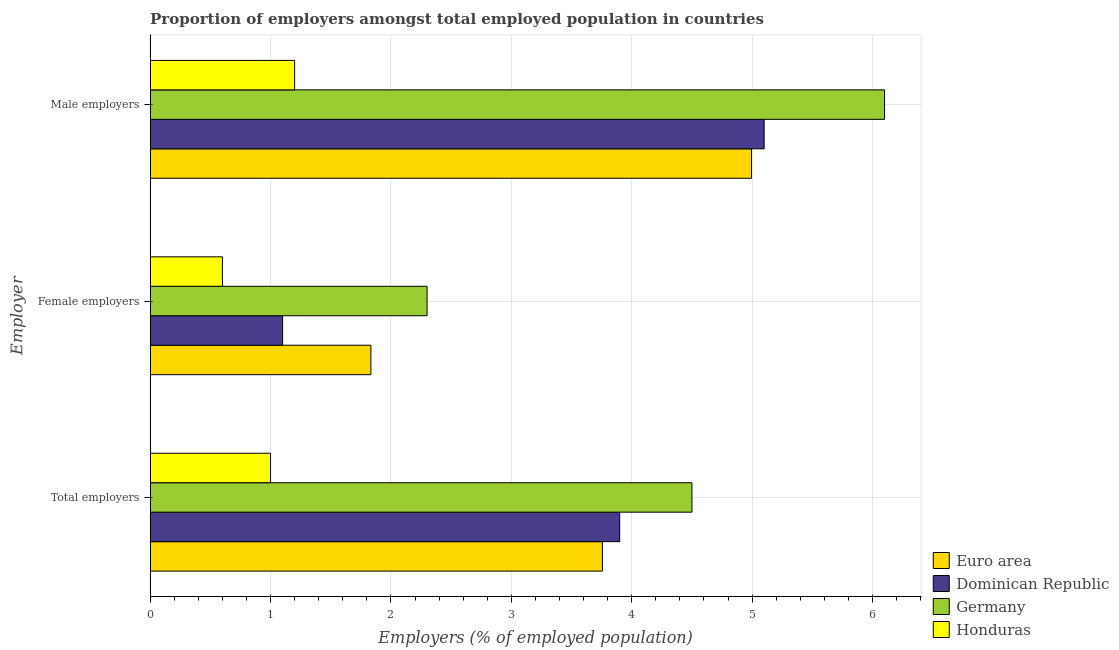How many different coloured bars are there?
Keep it short and to the point. 4. How many groups of bars are there?
Provide a short and direct response. 3. Are the number of bars on each tick of the Y-axis equal?
Your answer should be very brief. Yes. What is the label of the 2nd group of bars from the top?
Give a very brief answer. Female employers. What is the percentage of female employers in Honduras?
Your response must be concise. 0.6. Across all countries, what is the maximum percentage of female employers?
Offer a terse response. 2.3. In which country was the percentage of total employers minimum?
Your answer should be compact. Honduras. What is the total percentage of total employers in the graph?
Provide a succinct answer. 13.16. What is the difference between the percentage of total employers in Germany and that in Euro area?
Your answer should be compact. 0.74. What is the difference between the percentage of male employers in Honduras and the percentage of female employers in Germany?
Your response must be concise. -1.1. What is the average percentage of female employers per country?
Provide a succinct answer. 1.46. What is the difference between the percentage of female employers and percentage of total employers in Euro area?
Ensure brevity in your answer.  -1.92. What is the ratio of the percentage of total employers in Euro area to that in Germany?
Keep it short and to the point. 0.83. Is the difference between the percentage of total employers in Honduras and Germany greater than the difference between the percentage of female employers in Honduras and Germany?
Give a very brief answer. No. What is the difference between the highest and the second highest percentage of male employers?
Your answer should be compact. 1. What is the difference between the highest and the lowest percentage of female employers?
Give a very brief answer. 1.7. What does the 4th bar from the top in Female employers represents?
Your answer should be compact. Euro area. Is it the case that in every country, the sum of the percentage of total employers and percentage of female employers is greater than the percentage of male employers?
Your answer should be very brief. No. How many bars are there?
Make the answer very short. 12. Are all the bars in the graph horizontal?
Give a very brief answer. Yes. How many countries are there in the graph?
Keep it short and to the point. 4. What is the difference between two consecutive major ticks on the X-axis?
Your answer should be compact. 1. How many legend labels are there?
Give a very brief answer. 4. How are the legend labels stacked?
Your answer should be very brief. Vertical. What is the title of the graph?
Give a very brief answer. Proportion of employers amongst total employed population in countries. What is the label or title of the X-axis?
Your response must be concise. Employers (% of employed population). What is the label or title of the Y-axis?
Provide a short and direct response. Employer. What is the Employers (% of employed population) in Euro area in Total employers?
Offer a very short reply. 3.76. What is the Employers (% of employed population) in Dominican Republic in Total employers?
Provide a succinct answer. 3.9. What is the Employers (% of employed population) in Germany in Total employers?
Make the answer very short. 4.5. What is the Employers (% of employed population) in Euro area in Female employers?
Keep it short and to the point. 1.83. What is the Employers (% of employed population) of Dominican Republic in Female employers?
Keep it short and to the point. 1.1. What is the Employers (% of employed population) of Germany in Female employers?
Ensure brevity in your answer.  2.3. What is the Employers (% of employed population) of Honduras in Female employers?
Your response must be concise. 0.6. What is the Employers (% of employed population) in Euro area in Male employers?
Your response must be concise. 4.99. What is the Employers (% of employed population) of Dominican Republic in Male employers?
Provide a short and direct response. 5.1. What is the Employers (% of employed population) of Germany in Male employers?
Give a very brief answer. 6.1. What is the Employers (% of employed population) of Honduras in Male employers?
Provide a succinct answer. 1.2. Across all Employer, what is the maximum Employers (% of employed population) of Euro area?
Give a very brief answer. 4.99. Across all Employer, what is the maximum Employers (% of employed population) in Dominican Republic?
Your answer should be compact. 5.1. Across all Employer, what is the maximum Employers (% of employed population) of Germany?
Ensure brevity in your answer.  6.1. Across all Employer, what is the maximum Employers (% of employed population) in Honduras?
Offer a terse response. 1.2. Across all Employer, what is the minimum Employers (% of employed population) in Euro area?
Your answer should be compact. 1.83. Across all Employer, what is the minimum Employers (% of employed population) of Dominican Republic?
Ensure brevity in your answer.  1.1. Across all Employer, what is the minimum Employers (% of employed population) of Germany?
Make the answer very short. 2.3. Across all Employer, what is the minimum Employers (% of employed population) of Honduras?
Ensure brevity in your answer.  0.6. What is the total Employers (% of employed population) of Euro area in the graph?
Provide a succinct answer. 10.58. What is the total Employers (% of employed population) in Dominican Republic in the graph?
Your answer should be very brief. 10.1. What is the difference between the Employers (% of employed population) of Euro area in Total employers and that in Female employers?
Provide a succinct answer. 1.92. What is the difference between the Employers (% of employed population) in Dominican Republic in Total employers and that in Female employers?
Provide a short and direct response. 2.8. What is the difference between the Employers (% of employed population) of Euro area in Total employers and that in Male employers?
Make the answer very short. -1.24. What is the difference between the Employers (% of employed population) of Honduras in Total employers and that in Male employers?
Keep it short and to the point. -0.2. What is the difference between the Employers (% of employed population) of Euro area in Female employers and that in Male employers?
Offer a very short reply. -3.16. What is the difference between the Employers (% of employed population) in Dominican Republic in Female employers and that in Male employers?
Your response must be concise. -4. What is the difference between the Employers (% of employed population) in Euro area in Total employers and the Employers (% of employed population) in Dominican Republic in Female employers?
Your response must be concise. 2.66. What is the difference between the Employers (% of employed population) of Euro area in Total employers and the Employers (% of employed population) of Germany in Female employers?
Your response must be concise. 1.46. What is the difference between the Employers (% of employed population) of Euro area in Total employers and the Employers (% of employed population) of Honduras in Female employers?
Give a very brief answer. 3.16. What is the difference between the Employers (% of employed population) in Dominican Republic in Total employers and the Employers (% of employed population) in Honduras in Female employers?
Provide a succinct answer. 3.3. What is the difference between the Employers (% of employed population) in Germany in Total employers and the Employers (% of employed population) in Honduras in Female employers?
Your answer should be very brief. 3.9. What is the difference between the Employers (% of employed population) of Euro area in Total employers and the Employers (% of employed population) of Dominican Republic in Male employers?
Keep it short and to the point. -1.34. What is the difference between the Employers (% of employed population) in Euro area in Total employers and the Employers (% of employed population) in Germany in Male employers?
Ensure brevity in your answer.  -2.34. What is the difference between the Employers (% of employed population) of Euro area in Total employers and the Employers (% of employed population) of Honduras in Male employers?
Your response must be concise. 2.56. What is the difference between the Employers (% of employed population) of Dominican Republic in Total employers and the Employers (% of employed population) of Germany in Male employers?
Ensure brevity in your answer.  -2.2. What is the difference between the Employers (% of employed population) of Dominican Republic in Total employers and the Employers (% of employed population) of Honduras in Male employers?
Provide a succinct answer. 2.7. What is the difference between the Employers (% of employed population) of Euro area in Female employers and the Employers (% of employed population) of Dominican Republic in Male employers?
Make the answer very short. -3.27. What is the difference between the Employers (% of employed population) in Euro area in Female employers and the Employers (% of employed population) in Germany in Male employers?
Give a very brief answer. -4.27. What is the difference between the Employers (% of employed population) of Euro area in Female employers and the Employers (% of employed population) of Honduras in Male employers?
Provide a short and direct response. 0.63. What is the difference between the Employers (% of employed population) of Dominican Republic in Female employers and the Employers (% of employed population) of Germany in Male employers?
Make the answer very short. -5. What is the difference between the Employers (% of employed population) in Dominican Republic in Female employers and the Employers (% of employed population) in Honduras in Male employers?
Your answer should be compact. -0.1. What is the difference between the Employers (% of employed population) of Germany in Female employers and the Employers (% of employed population) of Honduras in Male employers?
Provide a short and direct response. 1.1. What is the average Employers (% of employed population) of Euro area per Employer?
Make the answer very short. 3.53. What is the average Employers (% of employed population) of Dominican Republic per Employer?
Make the answer very short. 3.37. What is the difference between the Employers (% of employed population) in Euro area and Employers (% of employed population) in Dominican Republic in Total employers?
Your answer should be compact. -0.14. What is the difference between the Employers (% of employed population) of Euro area and Employers (% of employed population) of Germany in Total employers?
Keep it short and to the point. -0.74. What is the difference between the Employers (% of employed population) of Euro area and Employers (% of employed population) of Honduras in Total employers?
Offer a very short reply. 2.76. What is the difference between the Employers (% of employed population) in Dominican Republic and Employers (% of employed population) in Germany in Total employers?
Your answer should be very brief. -0.6. What is the difference between the Employers (% of employed population) in Germany and Employers (% of employed population) in Honduras in Total employers?
Ensure brevity in your answer.  3.5. What is the difference between the Employers (% of employed population) in Euro area and Employers (% of employed population) in Dominican Republic in Female employers?
Make the answer very short. 0.73. What is the difference between the Employers (% of employed population) of Euro area and Employers (% of employed population) of Germany in Female employers?
Ensure brevity in your answer.  -0.47. What is the difference between the Employers (% of employed population) in Euro area and Employers (% of employed population) in Honduras in Female employers?
Make the answer very short. 1.23. What is the difference between the Employers (% of employed population) of Germany and Employers (% of employed population) of Honduras in Female employers?
Provide a short and direct response. 1.7. What is the difference between the Employers (% of employed population) of Euro area and Employers (% of employed population) of Dominican Republic in Male employers?
Offer a terse response. -0.11. What is the difference between the Employers (% of employed population) of Euro area and Employers (% of employed population) of Germany in Male employers?
Provide a short and direct response. -1.11. What is the difference between the Employers (% of employed population) of Euro area and Employers (% of employed population) of Honduras in Male employers?
Provide a succinct answer. 3.79. What is the difference between the Employers (% of employed population) in Dominican Republic and Employers (% of employed population) in Germany in Male employers?
Provide a short and direct response. -1. What is the difference between the Employers (% of employed population) in Dominican Republic and Employers (% of employed population) in Honduras in Male employers?
Your answer should be very brief. 3.9. What is the ratio of the Employers (% of employed population) in Euro area in Total employers to that in Female employers?
Offer a terse response. 2.05. What is the ratio of the Employers (% of employed population) of Dominican Republic in Total employers to that in Female employers?
Your response must be concise. 3.55. What is the ratio of the Employers (% of employed population) of Germany in Total employers to that in Female employers?
Make the answer very short. 1.96. What is the ratio of the Employers (% of employed population) of Honduras in Total employers to that in Female employers?
Ensure brevity in your answer.  1.67. What is the ratio of the Employers (% of employed population) in Euro area in Total employers to that in Male employers?
Offer a very short reply. 0.75. What is the ratio of the Employers (% of employed population) in Dominican Republic in Total employers to that in Male employers?
Your response must be concise. 0.76. What is the ratio of the Employers (% of employed population) in Germany in Total employers to that in Male employers?
Keep it short and to the point. 0.74. What is the ratio of the Employers (% of employed population) of Honduras in Total employers to that in Male employers?
Your response must be concise. 0.83. What is the ratio of the Employers (% of employed population) of Euro area in Female employers to that in Male employers?
Give a very brief answer. 0.37. What is the ratio of the Employers (% of employed population) in Dominican Republic in Female employers to that in Male employers?
Ensure brevity in your answer.  0.22. What is the ratio of the Employers (% of employed population) of Germany in Female employers to that in Male employers?
Make the answer very short. 0.38. What is the difference between the highest and the second highest Employers (% of employed population) of Euro area?
Offer a terse response. 1.24. What is the difference between the highest and the second highest Employers (% of employed population) in Germany?
Your answer should be very brief. 1.6. What is the difference between the highest and the lowest Employers (% of employed population) in Euro area?
Give a very brief answer. 3.16. What is the difference between the highest and the lowest Employers (% of employed population) of Dominican Republic?
Keep it short and to the point. 4. What is the difference between the highest and the lowest Employers (% of employed population) of Honduras?
Offer a very short reply. 0.6. 